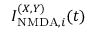Convert formula to latex. <formula><loc_0><loc_0><loc_500><loc_500>I _ { N M D A , i } ^ { ( X , Y ) } ( t )</formula> 